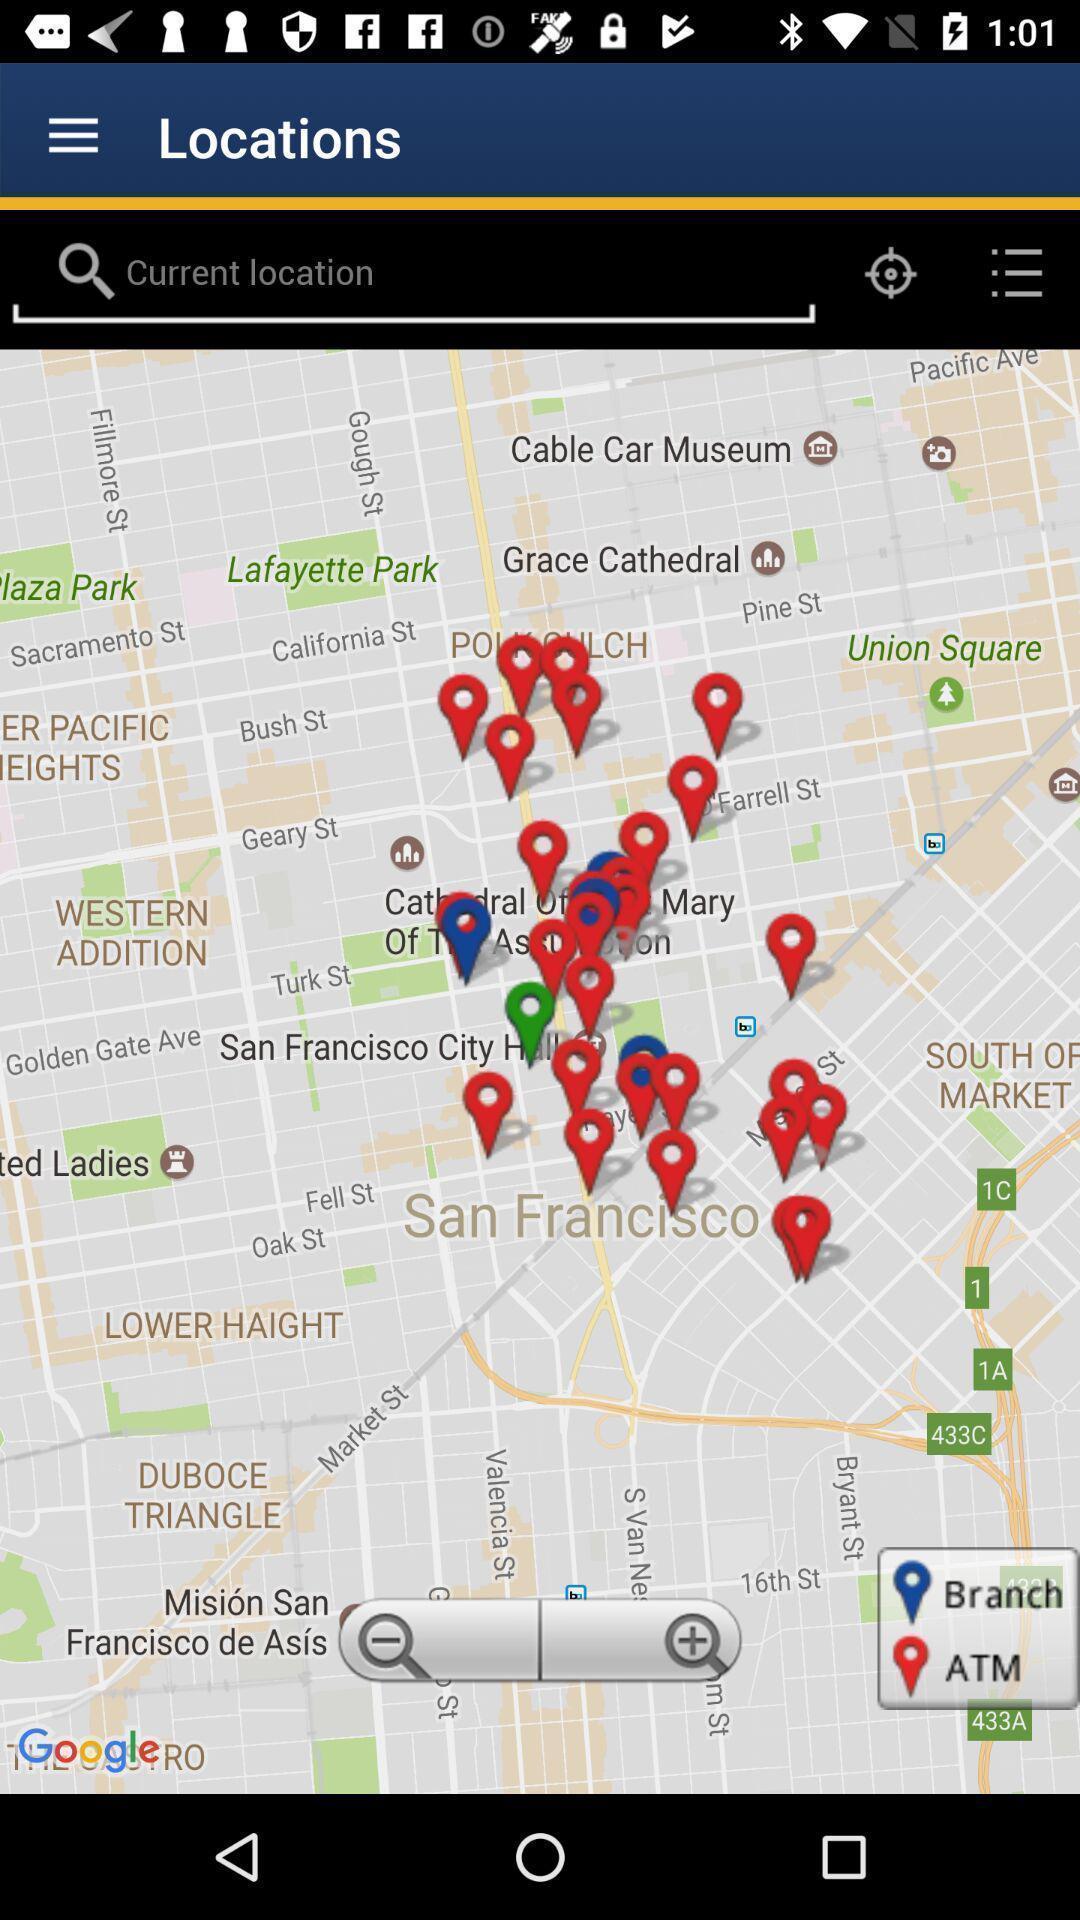Provide a detailed account of this screenshot. Search bar to search for the location. 